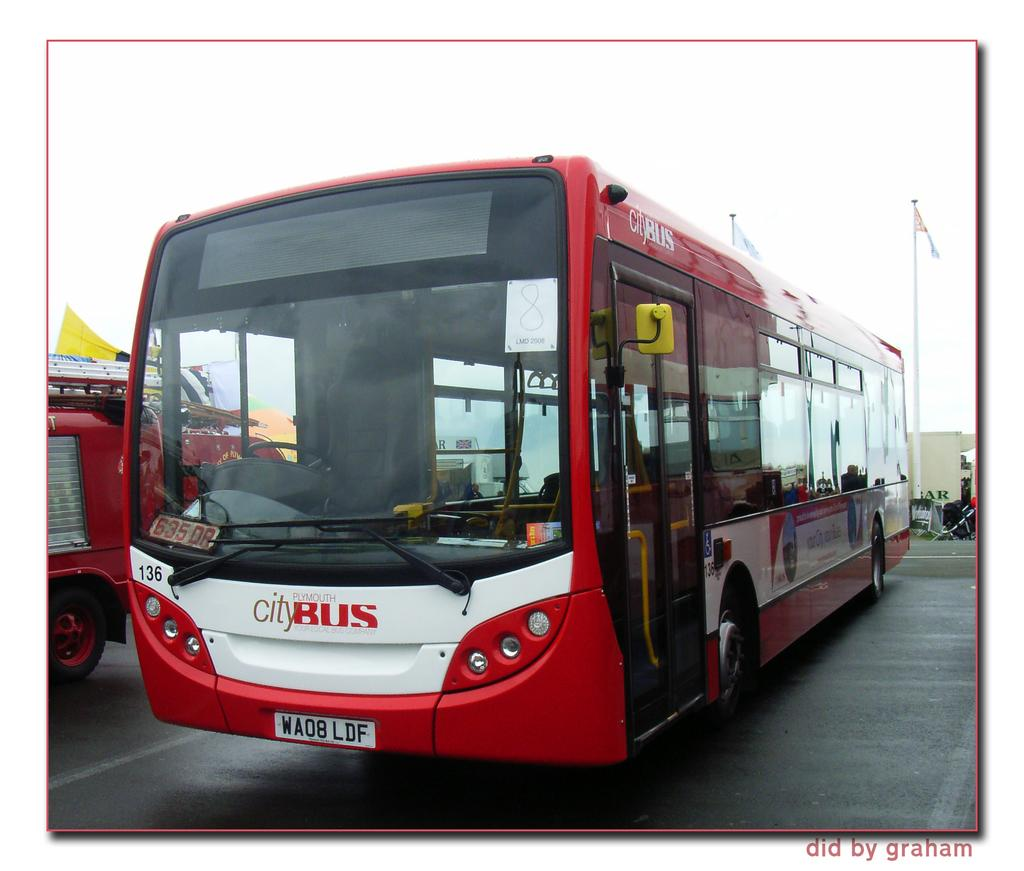<image>
Present a compact description of the photo's key features. A parked bus that belongs to the city of Plymouth. 